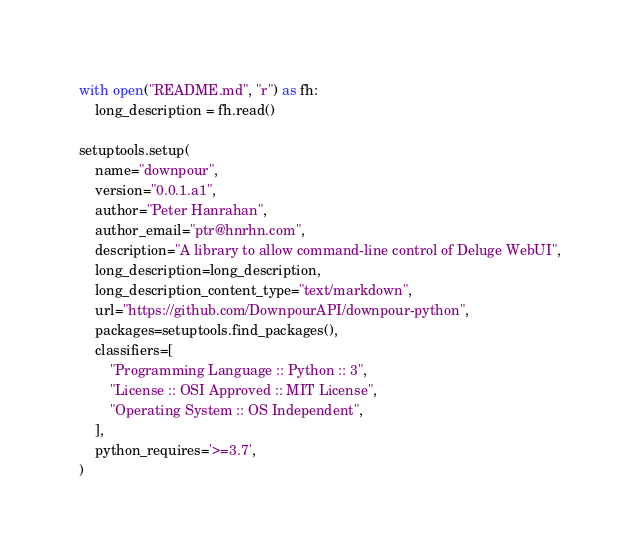Convert code to text. <code><loc_0><loc_0><loc_500><loc_500><_Python_>with open("README.md", "r") as fh:
    long_description = fh.read()

setuptools.setup(
    name="downpour",
    version="0.0.1.a1",
    author="Peter Hanrahan",
    author_email="ptr@hnrhn.com",
    description="A library to allow command-line control of Deluge WebUI",
    long_description=long_description,
    long_description_content_type="text/markdown",
    url="https://github.com/DownpourAPI/downpour-python",
    packages=setuptools.find_packages(),
    classifiers=[
        "Programming Language :: Python :: 3",
        "License :: OSI Approved :: MIT License",
        "Operating System :: OS Independent",
    ],
    python_requires='>=3.7',
)
</code> 